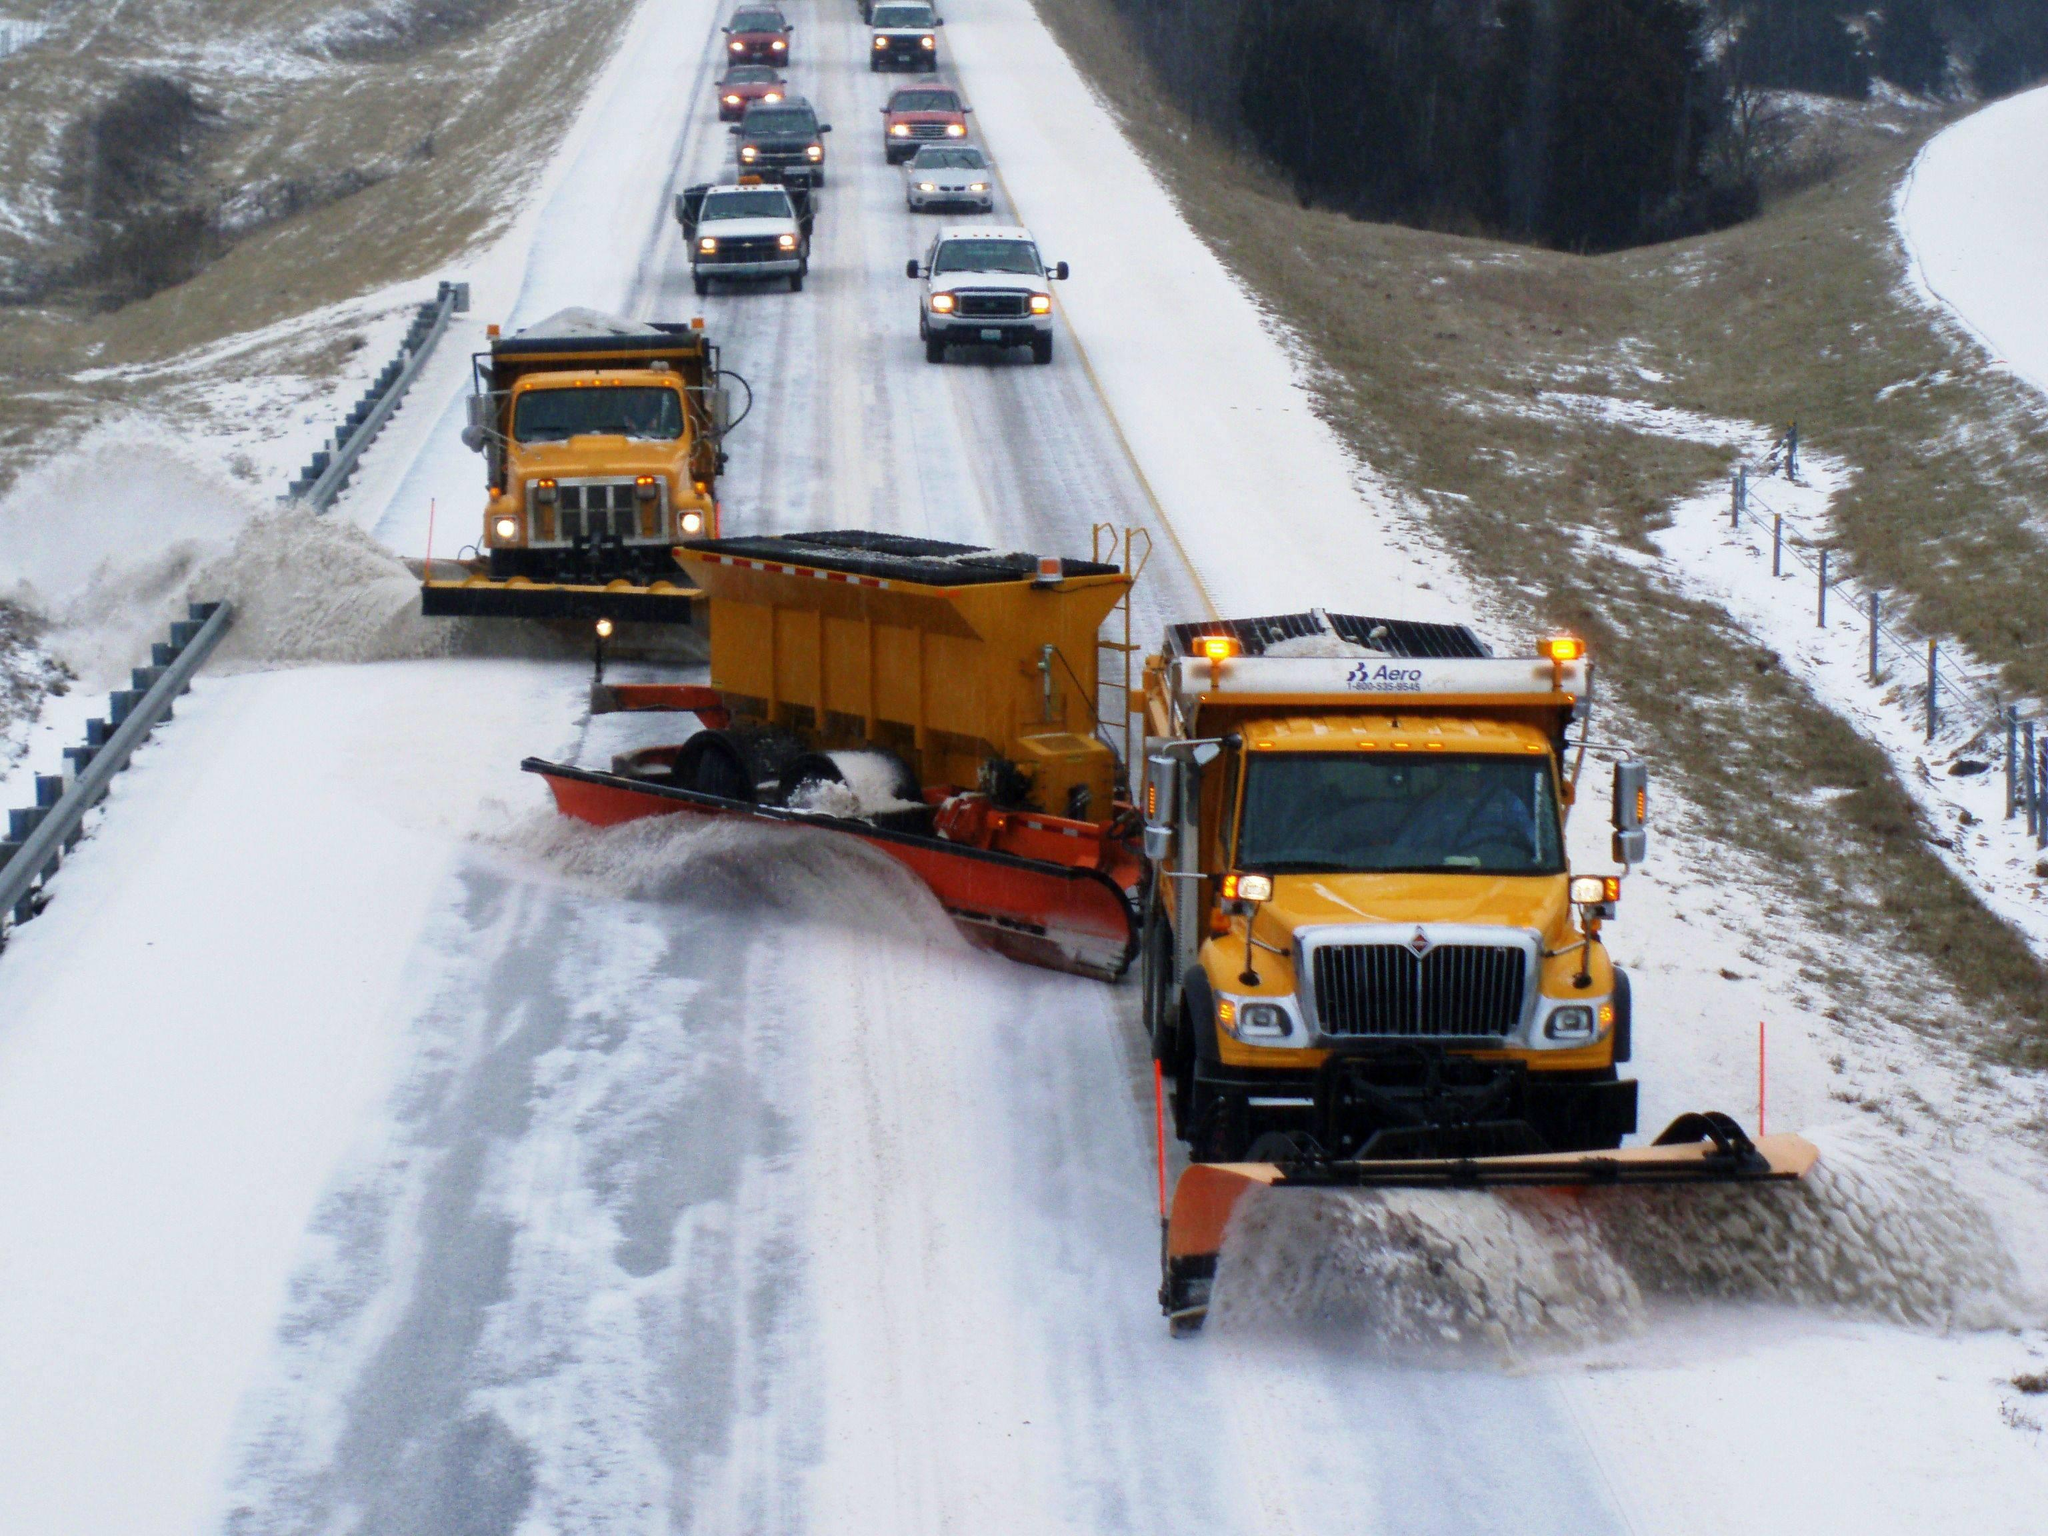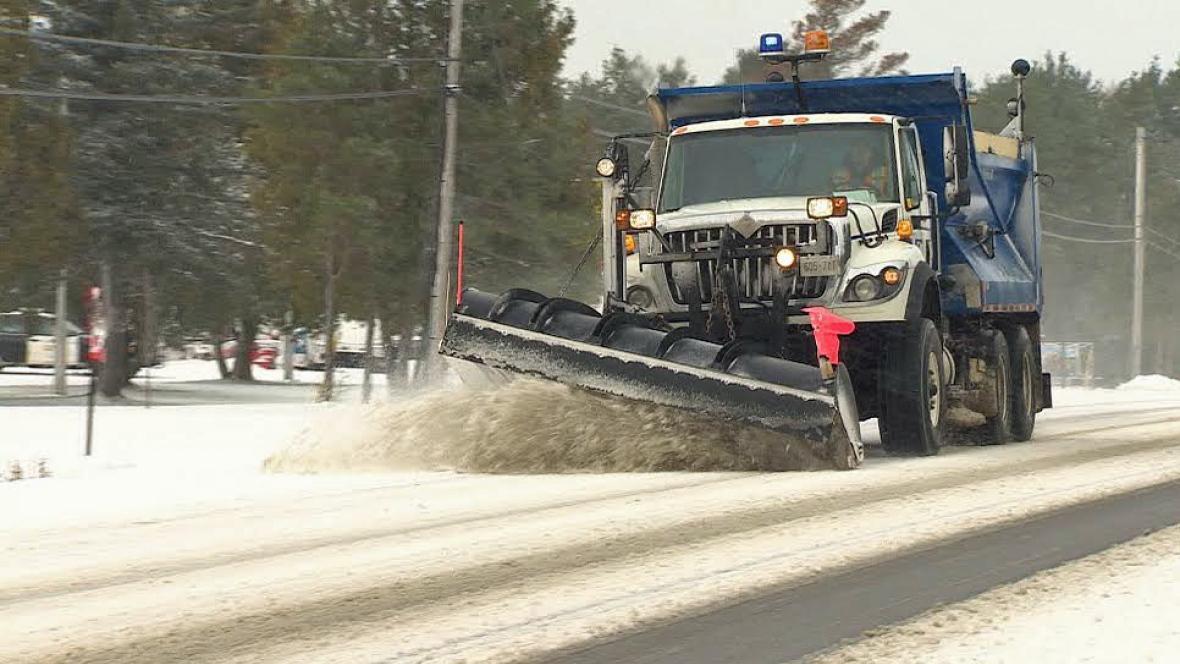The first image is the image on the left, the second image is the image on the right. For the images shown, is this caption "An image shows more than one snowplow truck on the same snowy road." true? Answer yes or no. Yes. 